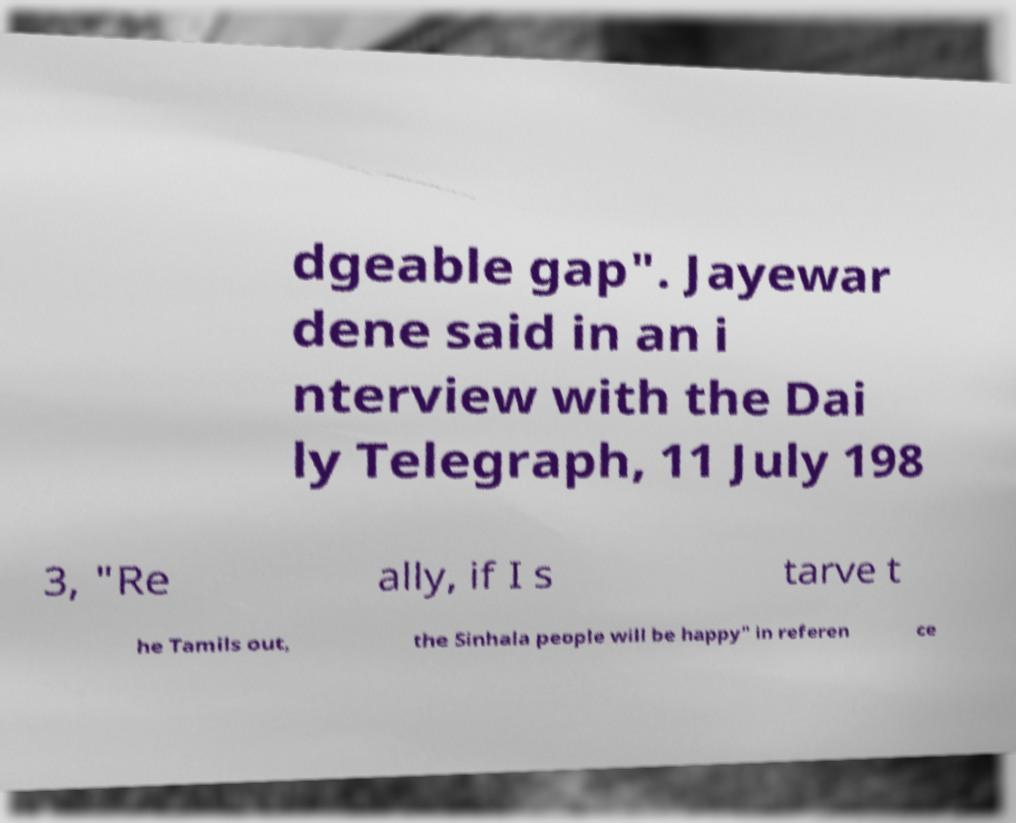What messages or text are displayed in this image? I need them in a readable, typed format. dgeable gap". Jayewar dene said in an i nterview with the Dai ly Telegraph, 11 July 198 3, "Re ally, if I s tarve t he Tamils out, the Sinhala people will be happy" in referen ce 